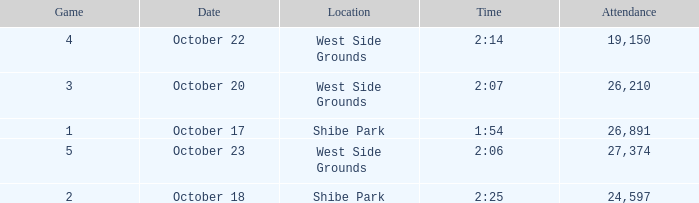Which week was the first game played that had a time of 2:06 and less than 27,374 attendees? None. 